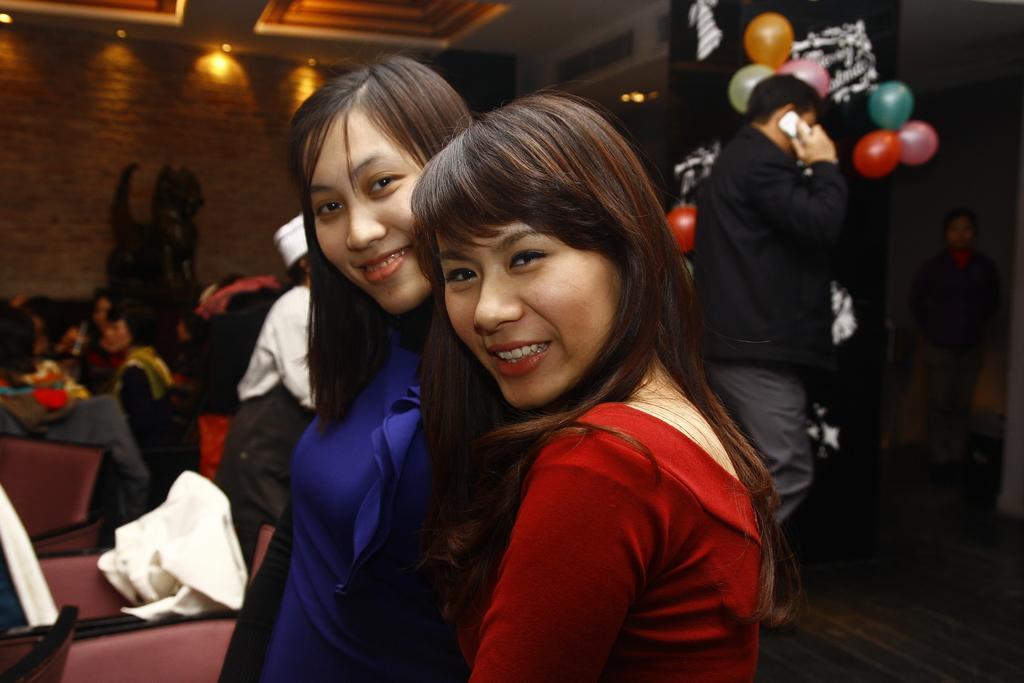Could you give a brief overview of what you see in this image? In this image I can see number of people and I can see smile on few faces. In the background I can see few lights and few balloons. I can also see this image is little bit blurry from background. 